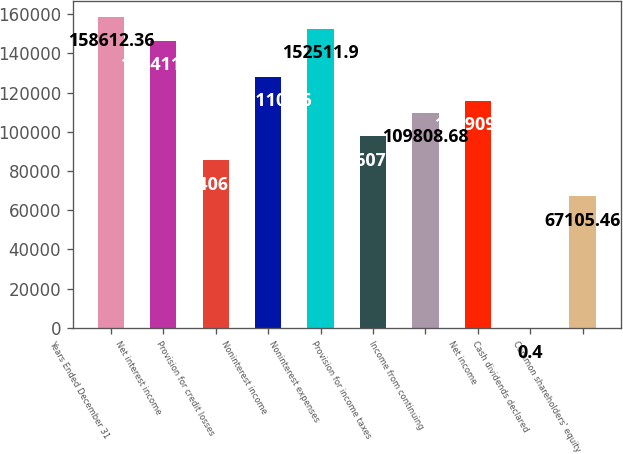<chart> <loc_0><loc_0><loc_500><loc_500><bar_chart><fcel>Years Ended December 31<fcel>Net interest income<fcel>Provision for credit losses<fcel>Noninterest income<fcel>Noninterest expenses<fcel>Provision for income taxes<fcel>Income from continuing<fcel>Net income<fcel>Cash dividends declared<fcel>Common shareholders' equity<nl><fcel>158612<fcel>146411<fcel>85406.8<fcel>128110<fcel>152512<fcel>97607.8<fcel>109809<fcel>115909<fcel>0.4<fcel>67105.5<nl></chart> 